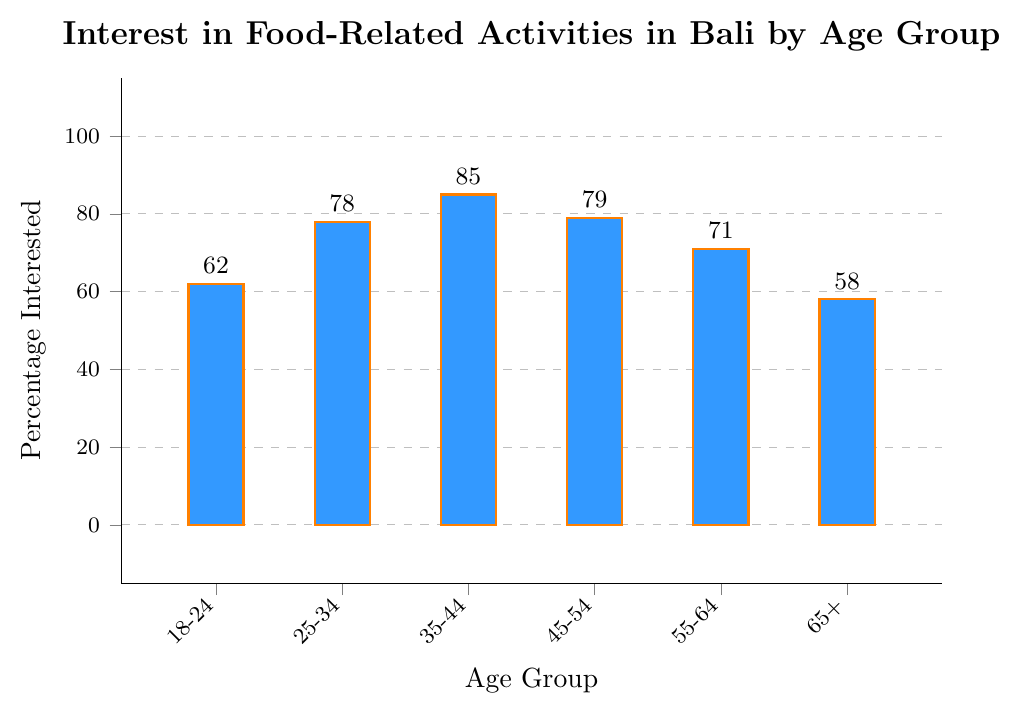What age group shows the highest percentage of interest in food-related activities in Bali? The bar corresponding to the age group 35-44 has the tallest height, indicating the highest percentage.
Answer: 35-44 Which age group has a lower percentage of interest in food-related activities, 18-24 or 65+? The height of the bar for the age group 65+ is shorter than that for the age group 18-24, representing a lower percentage.
Answer: 65+ What is the difference in percentage interest between the age groups 35-44 and 55-64? The heights of the bars for age groups 35-44 and 55-64 are 85% and 71%, respectively. The difference is 85 - 71.
Answer: 14 What is the average percentage interest for the age groups 18-24, 25-34, and 35-44? The percentages for the age groups 18-24, 25-34, and 35-44 are 62, 78, and 85. The average is (62 + 78 + 85) / 3.
Answer: 75 Which age group has a larger percentage of interest, 25-34 or 45-54? The bar for the age group 45-54 is slightly taller than the one for 25-34, indicating a higher percentage.
Answer: 45-54 What is the total percentage interest for all age groups combined? The percentages are 62, 78, 85, 79, 71, and 58. The total is 62 + 78 + 85 + 79 + 71 + 58.
Answer: 433 Is the interest in food-related activities in Bali greater in the age group 55-64 or 18-24? Comparing the heights of the bars, the age group 55-64 has a taller bar than 18-24, indicating a higher percentage.
Answer: 55-64 Which two age groups have the closest percentage of interest in food-related activities? The percentages for the age groups 25-34 and 45-54 are 78% and 79%, respectively, which are the closest to each other.
Answer: 25-34 and 45-54 What is the median percentage interest in food-related activities in Bali across all age groups? The percentages sorted in ascending order are 58%, 62%, 71%, 78%, 79%, and 85%. The middle values are 71% and 78%, so the median is (71 + 78) / 2.
Answer: 74.5 